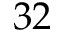Convert formula to latex. <formula><loc_0><loc_0><loc_500><loc_500>3 2</formula> 